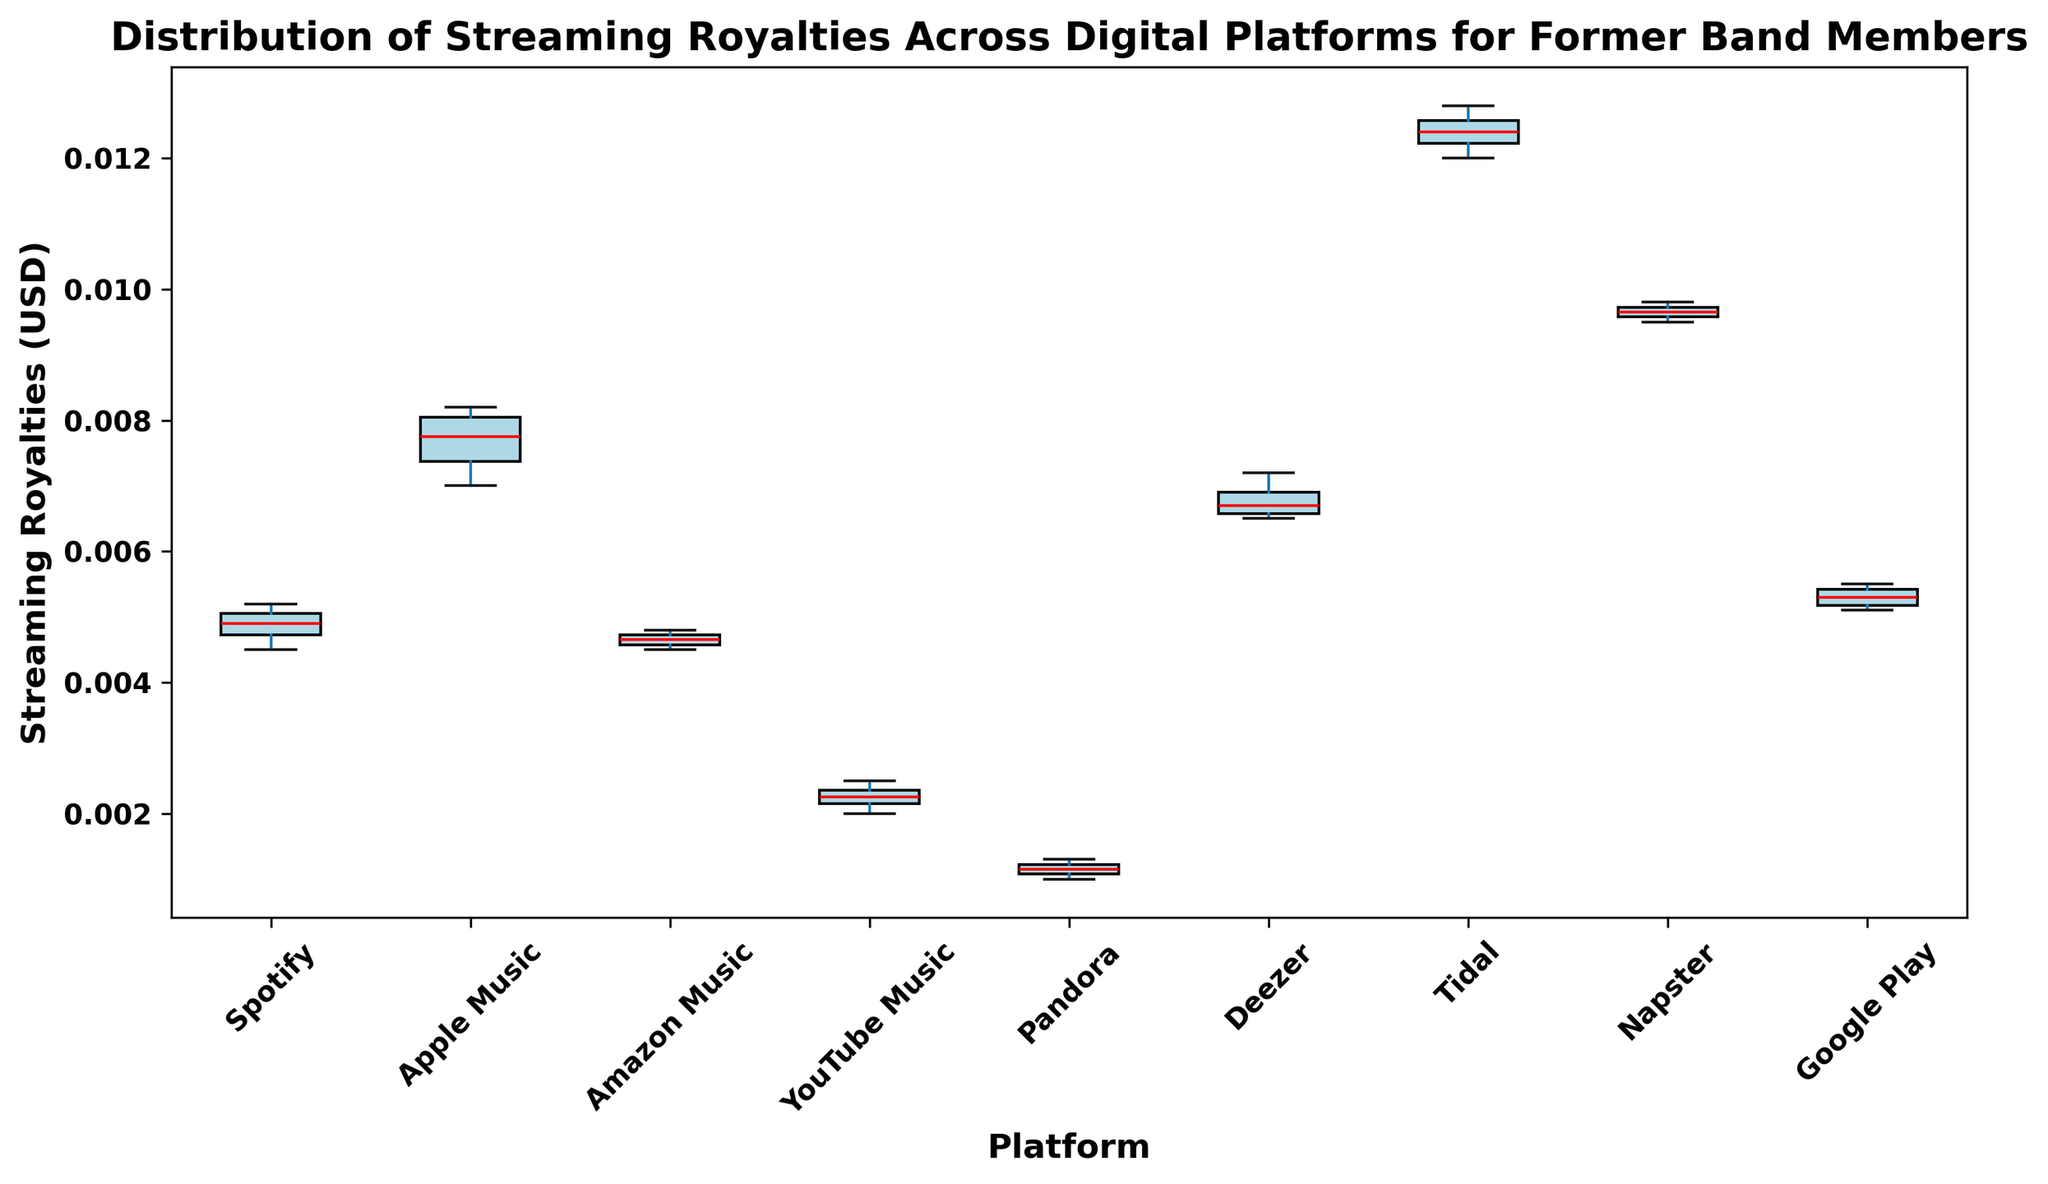Which platform has the highest median streaming royalty? By looking at the red lines (representing the medians) in the box plots, identify the highest one. The box plot for Tidal has the highest median.
Answer: Tidal What is the range of streaming royalties for Spotify? To find the range, identify the minimum and maximum ends of the whiskers for Spotify. The minimum is 0.0045 and the maximum is 0.0052. The range is the difference: 0.0052 - 0.0045.
Answer: 0.0007 Comparing YouTube Music and Pandora, which platform has the broader spread of royalties? The broader spread is indicated by a larger interquartile range (IQR). YouTube Music's box (IQR) is wider than Pandora's box.
Answer: YouTube Music What's the interquartile range (IQR) for Apple Music? To find the IQR, identify the first quartile (Q1) and the third quartile (Q3) for Apple Music. The IQR is Q3 - Q1. From the boxplot, Q3 is around 0.008 and Q1 is around 0.007.
Answer: 0.001 How do the median royalties of Google Play and Amazon Music compare? Look at the red lines within the box plots for Google Play and Amazon Music. The median for Google Play is higher than that for Amazon Music.
Answer: Google Play is higher Which platform shows the most consistent royalties among members? Consistency is indicated by a smaller spread (range) in the box plot. Pandora shows the smallest range among the platforms.
Answer: Pandora What is the order of platforms from highest to lowest median royalties? Look at the red lines (medians) and arrange the platforms in descending order: Tidal, Napster, Apple Music, Deezer, Google Play, Spotify, Amazon Music, YouTube Music, Pandora.
Answer: Tidal, Napster, Apple Music, Deezer, Google Play, Spotify, Amazon Music, YouTube Music, Pandora What is the median value for Deezer, and how does it compare to the median value for Napster? Identify the red line (median) for both Deezer and Napster. Deezer's median is approximately 0.0068 and Napster's is around 0.0096. Napster's median is higher.
Answer: Deezer: ~0.0068, Napster: ~0.0096; Napster is higher 